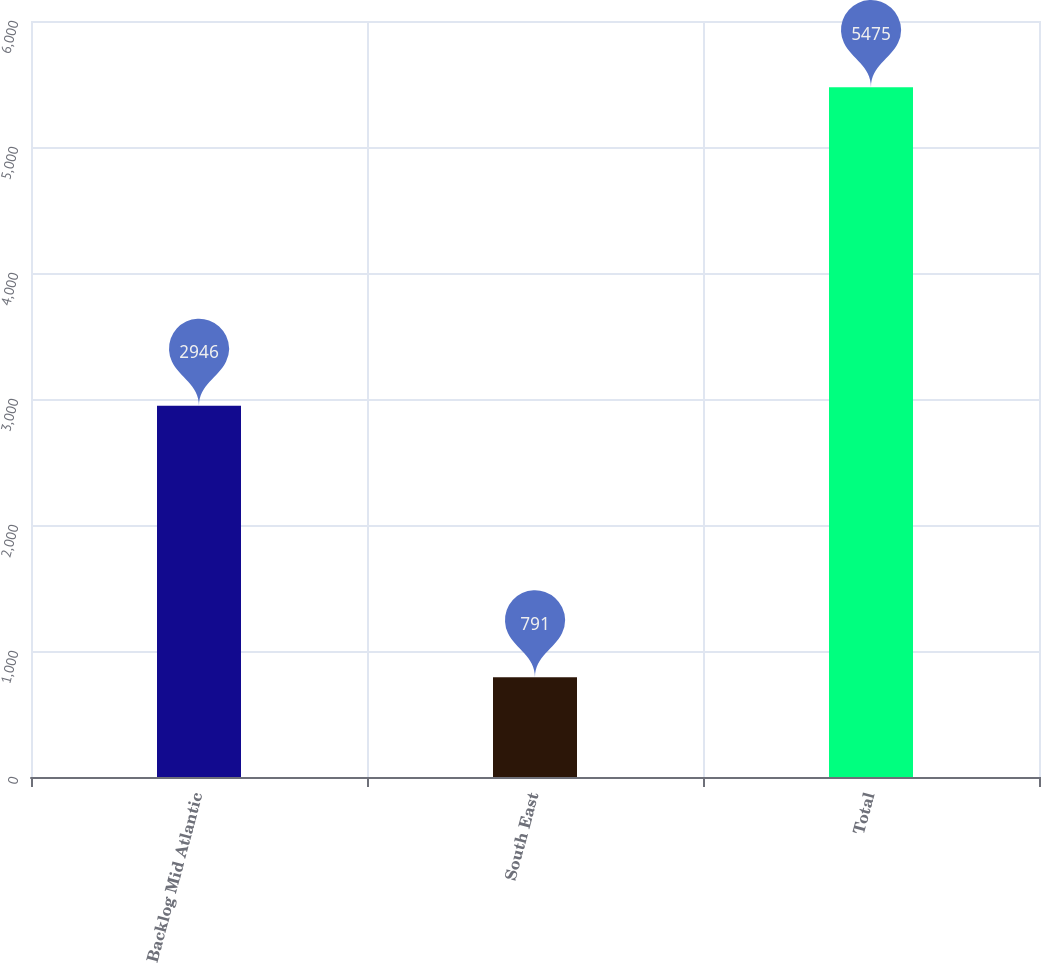Convert chart to OTSL. <chart><loc_0><loc_0><loc_500><loc_500><bar_chart><fcel>Backlog Mid Atlantic<fcel>South East<fcel>Total<nl><fcel>2946<fcel>791<fcel>5475<nl></chart> 